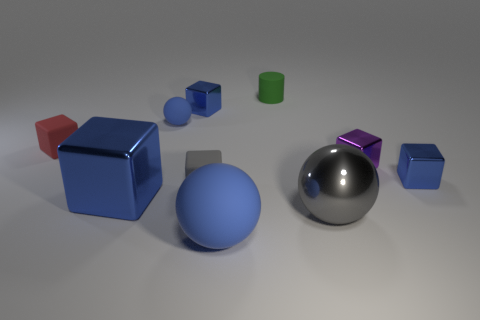Subtract all red rubber blocks. How many blocks are left? 5 Subtract all cylinders. How many objects are left? 9 Subtract all brown cylinders. How many blue spheres are left? 2 Subtract all red cubes. How many cubes are left? 5 Subtract 2 blocks. How many blocks are left? 4 Subtract all big gray spheres. Subtract all tiny green rubber cylinders. How many objects are left? 8 Add 9 large matte things. How many large matte things are left? 10 Add 6 red matte objects. How many red matte objects exist? 7 Subtract 0 gray cylinders. How many objects are left? 10 Subtract all purple cylinders. Subtract all yellow blocks. How many cylinders are left? 1 